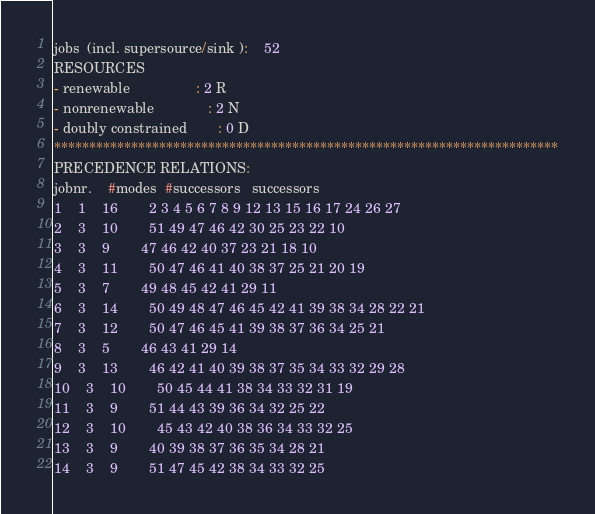<code> <loc_0><loc_0><loc_500><loc_500><_ObjectiveC_>jobs  (incl. supersource/sink ):	52
RESOURCES
- renewable                 : 2 R
- nonrenewable              : 2 N
- doubly constrained        : 0 D
************************************************************************
PRECEDENCE RELATIONS:
jobnr.    #modes  #successors   successors
1	1	16		2 3 4 5 6 7 8 9 12 13 15 16 17 24 26 27 
2	3	10		51 49 47 46 42 30 25 23 22 10 
3	3	9		47 46 42 40 37 23 21 18 10 
4	3	11		50 47 46 41 40 38 37 25 21 20 19 
5	3	7		49 48 45 42 41 29 11 
6	3	14		50 49 48 47 46 45 42 41 39 38 34 28 22 21 
7	3	12		50 47 46 45 41 39 38 37 36 34 25 21 
8	3	5		46 43 41 29 14 
9	3	13		46 42 41 40 39 38 37 35 34 33 32 29 28 
10	3	10		50 45 44 41 38 34 33 32 31 19 
11	3	9		51 44 43 39 36 34 32 25 22 
12	3	10		45 43 42 40 38 36 34 33 32 25 
13	3	9		40 39 38 37 36 35 34 28 21 
14	3	9		51 47 45 42 38 34 33 32 25 </code> 